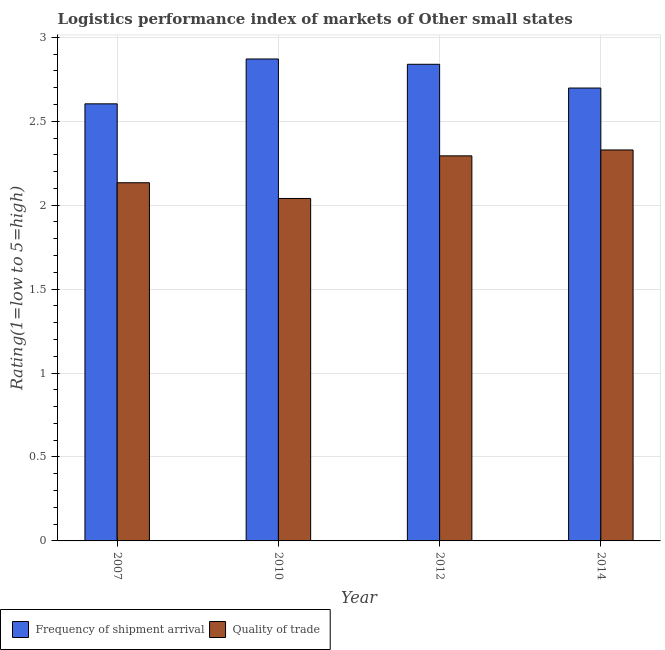How many different coloured bars are there?
Provide a short and direct response. 2. Are the number of bars per tick equal to the number of legend labels?
Make the answer very short. Yes. How many bars are there on the 4th tick from the left?
Make the answer very short. 2. How many bars are there on the 2nd tick from the right?
Your answer should be compact. 2. In how many cases, is the number of bars for a given year not equal to the number of legend labels?
Your answer should be very brief. 0. What is the lpi quality of trade in 2012?
Make the answer very short. 2.29. Across all years, what is the maximum lpi quality of trade?
Provide a succinct answer. 2.33. Across all years, what is the minimum lpi quality of trade?
Provide a succinct answer. 2.04. What is the total lpi quality of trade in the graph?
Your response must be concise. 8.8. What is the difference between the lpi quality of trade in 2010 and that in 2012?
Offer a very short reply. -0.25. What is the difference between the lpi of frequency of shipment arrival in 2012 and the lpi quality of trade in 2014?
Provide a short and direct response. 0.14. What is the average lpi quality of trade per year?
Make the answer very short. 2.2. In the year 2014, what is the difference between the lpi of frequency of shipment arrival and lpi quality of trade?
Your answer should be very brief. 0. In how many years, is the lpi quality of trade greater than 2.7?
Offer a terse response. 0. What is the ratio of the lpi quality of trade in 2010 to that in 2014?
Make the answer very short. 0.88. Is the difference between the lpi quality of trade in 2010 and 2012 greater than the difference between the lpi of frequency of shipment arrival in 2010 and 2012?
Give a very brief answer. No. What is the difference between the highest and the second highest lpi of frequency of shipment arrival?
Keep it short and to the point. 0.03. What is the difference between the highest and the lowest lpi quality of trade?
Your answer should be compact. 0.29. Is the sum of the lpi of frequency of shipment arrival in 2007 and 2012 greater than the maximum lpi quality of trade across all years?
Provide a succinct answer. Yes. What does the 2nd bar from the left in 2014 represents?
Offer a very short reply. Quality of trade. What does the 1st bar from the right in 2007 represents?
Provide a short and direct response. Quality of trade. Are all the bars in the graph horizontal?
Ensure brevity in your answer.  No. How many years are there in the graph?
Keep it short and to the point. 4. Are the values on the major ticks of Y-axis written in scientific E-notation?
Make the answer very short. No. Does the graph contain grids?
Your answer should be compact. Yes. Where does the legend appear in the graph?
Give a very brief answer. Bottom left. How many legend labels are there?
Ensure brevity in your answer.  2. What is the title of the graph?
Ensure brevity in your answer.  Logistics performance index of markets of Other small states. What is the label or title of the Y-axis?
Your response must be concise. Rating(1=low to 5=high). What is the Rating(1=low to 5=high) of Frequency of shipment arrival in 2007?
Offer a very short reply. 2.6. What is the Rating(1=low to 5=high) in Quality of trade in 2007?
Keep it short and to the point. 2.13. What is the Rating(1=low to 5=high) of Frequency of shipment arrival in 2010?
Make the answer very short. 2.87. What is the Rating(1=low to 5=high) in Quality of trade in 2010?
Provide a short and direct response. 2.04. What is the Rating(1=low to 5=high) of Frequency of shipment arrival in 2012?
Give a very brief answer. 2.84. What is the Rating(1=low to 5=high) of Quality of trade in 2012?
Ensure brevity in your answer.  2.29. What is the Rating(1=low to 5=high) in Frequency of shipment arrival in 2014?
Give a very brief answer. 2.7. What is the Rating(1=low to 5=high) in Quality of trade in 2014?
Provide a succinct answer. 2.33. Across all years, what is the maximum Rating(1=low to 5=high) of Frequency of shipment arrival?
Provide a succinct answer. 2.87. Across all years, what is the maximum Rating(1=low to 5=high) of Quality of trade?
Provide a short and direct response. 2.33. Across all years, what is the minimum Rating(1=low to 5=high) in Frequency of shipment arrival?
Make the answer very short. 2.6. Across all years, what is the minimum Rating(1=low to 5=high) in Quality of trade?
Keep it short and to the point. 2.04. What is the total Rating(1=low to 5=high) of Frequency of shipment arrival in the graph?
Ensure brevity in your answer.  11.01. What is the total Rating(1=low to 5=high) in Quality of trade in the graph?
Ensure brevity in your answer.  8.8. What is the difference between the Rating(1=low to 5=high) of Frequency of shipment arrival in 2007 and that in 2010?
Offer a terse response. -0.27. What is the difference between the Rating(1=low to 5=high) of Quality of trade in 2007 and that in 2010?
Make the answer very short. 0.09. What is the difference between the Rating(1=low to 5=high) in Frequency of shipment arrival in 2007 and that in 2012?
Offer a very short reply. -0.24. What is the difference between the Rating(1=low to 5=high) of Quality of trade in 2007 and that in 2012?
Your answer should be very brief. -0.16. What is the difference between the Rating(1=low to 5=high) in Frequency of shipment arrival in 2007 and that in 2014?
Your answer should be compact. -0.09. What is the difference between the Rating(1=low to 5=high) of Quality of trade in 2007 and that in 2014?
Offer a terse response. -0.2. What is the difference between the Rating(1=low to 5=high) in Frequency of shipment arrival in 2010 and that in 2012?
Your answer should be compact. 0.03. What is the difference between the Rating(1=low to 5=high) of Quality of trade in 2010 and that in 2012?
Make the answer very short. -0.25. What is the difference between the Rating(1=low to 5=high) in Frequency of shipment arrival in 2010 and that in 2014?
Offer a very short reply. 0.17. What is the difference between the Rating(1=low to 5=high) in Quality of trade in 2010 and that in 2014?
Your response must be concise. -0.29. What is the difference between the Rating(1=low to 5=high) in Frequency of shipment arrival in 2012 and that in 2014?
Keep it short and to the point. 0.14. What is the difference between the Rating(1=low to 5=high) in Quality of trade in 2012 and that in 2014?
Ensure brevity in your answer.  -0.04. What is the difference between the Rating(1=low to 5=high) of Frequency of shipment arrival in 2007 and the Rating(1=low to 5=high) of Quality of trade in 2010?
Make the answer very short. 0.56. What is the difference between the Rating(1=low to 5=high) of Frequency of shipment arrival in 2007 and the Rating(1=low to 5=high) of Quality of trade in 2012?
Ensure brevity in your answer.  0.31. What is the difference between the Rating(1=low to 5=high) in Frequency of shipment arrival in 2007 and the Rating(1=low to 5=high) in Quality of trade in 2014?
Provide a succinct answer. 0.27. What is the difference between the Rating(1=low to 5=high) in Frequency of shipment arrival in 2010 and the Rating(1=low to 5=high) in Quality of trade in 2012?
Your response must be concise. 0.58. What is the difference between the Rating(1=low to 5=high) of Frequency of shipment arrival in 2010 and the Rating(1=low to 5=high) of Quality of trade in 2014?
Your answer should be very brief. 0.54. What is the difference between the Rating(1=low to 5=high) in Frequency of shipment arrival in 2012 and the Rating(1=low to 5=high) in Quality of trade in 2014?
Give a very brief answer. 0.51. What is the average Rating(1=low to 5=high) in Frequency of shipment arrival per year?
Your answer should be very brief. 2.75. What is the average Rating(1=low to 5=high) of Quality of trade per year?
Your answer should be compact. 2.2. In the year 2007, what is the difference between the Rating(1=low to 5=high) of Frequency of shipment arrival and Rating(1=low to 5=high) of Quality of trade?
Provide a succinct answer. 0.47. In the year 2010, what is the difference between the Rating(1=low to 5=high) in Frequency of shipment arrival and Rating(1=low to 5=high) in Quality of trade?
Your answer should be compact. 0.83. In the year 2012, what is the difference between the Rating(1=low to 5=high) of Frequency of shipment arrival and Rating(1=low to 5=high) of Quality of trade?
Your answer should be compact. 0.55. In the year 2014, what is the difference between the Rating(1=low to 5=high) of Frequency of shipment arrival and Rating(1=low to 5=high) of Quality of trade?
Provide a succinct answer. 0.37. What is the ratio of the Rating(1=low to 5=high) of Frequency of shipment arrival in 2007 to that in 2010?
Provide a short and direct response. 0.91. What is the ratio of the Rating(1=low to 5=high) in Quality of trade in 2007 to that in 2010?
Your answer should be compact. 1.05. What is the ratio of the Rating(1=low to 5=high) in Frequency of shipment arrival in 2007 to that in 2012?
Provide a succinct answer. 0.92. What is the ratio of the Rating(1=low to 5=high) in Quality of trade in 2007 to that in 2012?
Offer a terse response. 0.93. What is the ratio of the Rating(1=low to 5=high) in Frequency of shipment arrival in 2007 to that in 2014?
Your answer should be very brief. 0.97. What is the ratio of the Rating(1=low to 5=high) in Quality of trade in 2007 to that in 2014?
Keep it short and to the point. 0.92. What is the ratio of the Rating(1=low to 5=high) in Frequency of shipment arrival in 2010 to that in 2012?
Provide a succinct answer. 1.01. What is the ratio of the Rating(1=low to 5=high) of Quality of trade in 2010 to that in 2012?
Give a very brief answer. 0.89. What is the ratio of the Rating(1=low to 5=high) in Frequency of shipment arrival in 2010 to that in 2014?
Provide a succinct answer. 1.06. What is the ratio of the Rating(1=low to 5=high) of Quality of trade in 2010 to that in 2014?
Your answer should be compact. 0.88. What is the ratio of the Rating(1=low to 5=high) in Frequency of shipment arrival in 2012 to that in 2014?
Make the answer very short. 1.05. What is the ratio of the Rating(1=low to 5=high) of Quality of trade in 2012 to that in 2014?
Your answer should be very brief. 0.98. What is the difference between the highest and the second highest Rating(1=low to 5=high) in Frequency of shipment arrival?
Give a very brief answer. 0.03. What is the difference between the highest and the second highest Rating(1=low to 5=high) of Quality of trade?
Offer a very short reply. 0.04. What is the difference between the highest and the lowest Rating(1=low to 5=high) in Frequency of shipment arrival?
Provide a succinct answer. 0.27. What is the difference between the highest and the lowest Rating(1=low to 5=high) in Quality of trade?
Your answer should be compact. 0.29. 